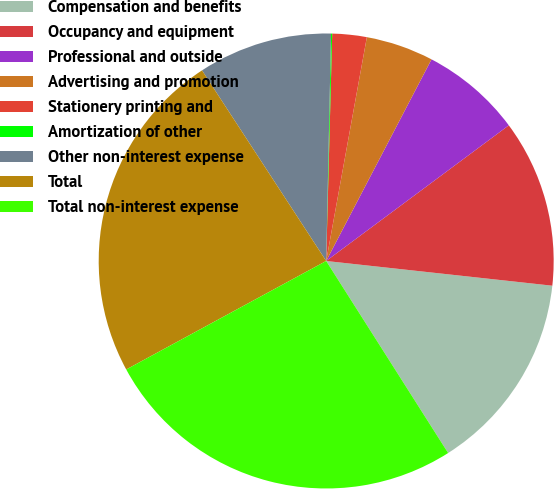<chart> <loc_0><loc_0><loc_500><loc_500><pie_chart><fcel>Compensation and benefits<fcel>Occupancy and equipment<fcel>Professional and outside<fcel>Advertising and promotion<fcel>Stationery printing and<fcel>Amortization of other<fcel>Other non-interest expense<fcel>Total<fcel>Total non-interest expense<nl><fcel>14.26%<fcel>11.9%<fcel>7.17%<fcel>4.8%<fcel>2.44%<fcel>0.08%<fcel>9.53%<fcel>23.72%<fcel>26.09%<nl></chart> 